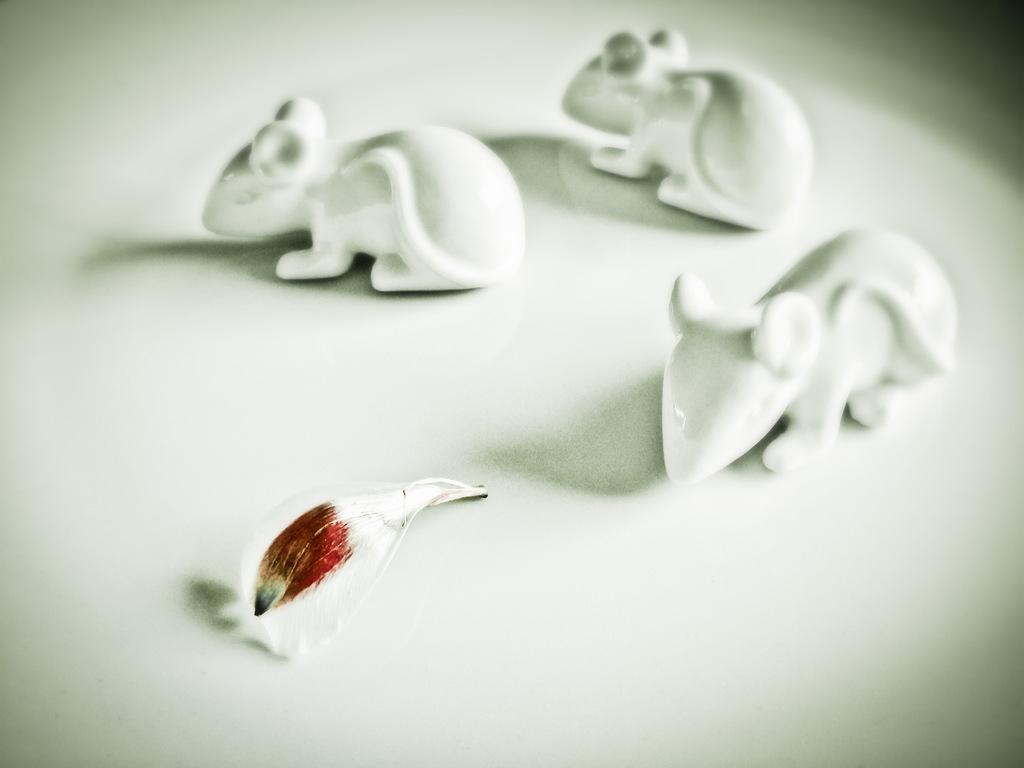What color can be observed in the objects present in the image? There are objects in the image that are white in color. Can you describe an object that has more than one color in the image? There is an object in the image that is white and red in color. How many beds are present in the image? There is no information about beds in the image, so it cannot be determined from the facts provided. 